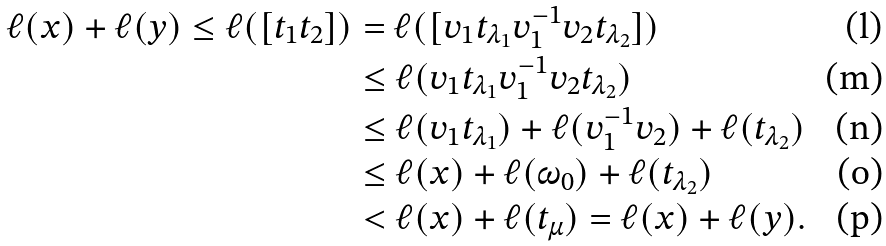Convert formula to latex. <formula><loc_0><loc_0><loc_500><loc_500>\ell ( x ) + \ell ( y ) \leq \ell ( [ t _ { 1 } t _ { 2 } ] ) & = \ell ( [ v _ { 1 } t _ { \lambda _ { 1 } } v _ { 1 } ^ { - 1 } v _ { 2 } t _ { \lambda _ { 2 } } ] ) \\ & \leq \ell ( v _ { 1 } t _ { \lambda _ { 1 } } v _ { 1 } ^ { - 1 } v _ { 2 } t _ { \lambda _ { 2 } } ) \\ & \leq \ell ( v _ { 1 } t _ { \lambda _ { 1 } } ) + \ell ( v _ { 1 } ^ { - 1 } v _ { 2 } ) + \ell ( t _ { \lambda _ { 2 } } ) \\ & \leq \ell ( x ) + \ell ( \omega _ { 0 } ) + \ell ( t _ { \lambda _ { 2 } } ) \\ & < \ell ( x ) + \ell ( t _ { \mu } ) = \ell ( x ) + \ell ( y ) .</formula> 